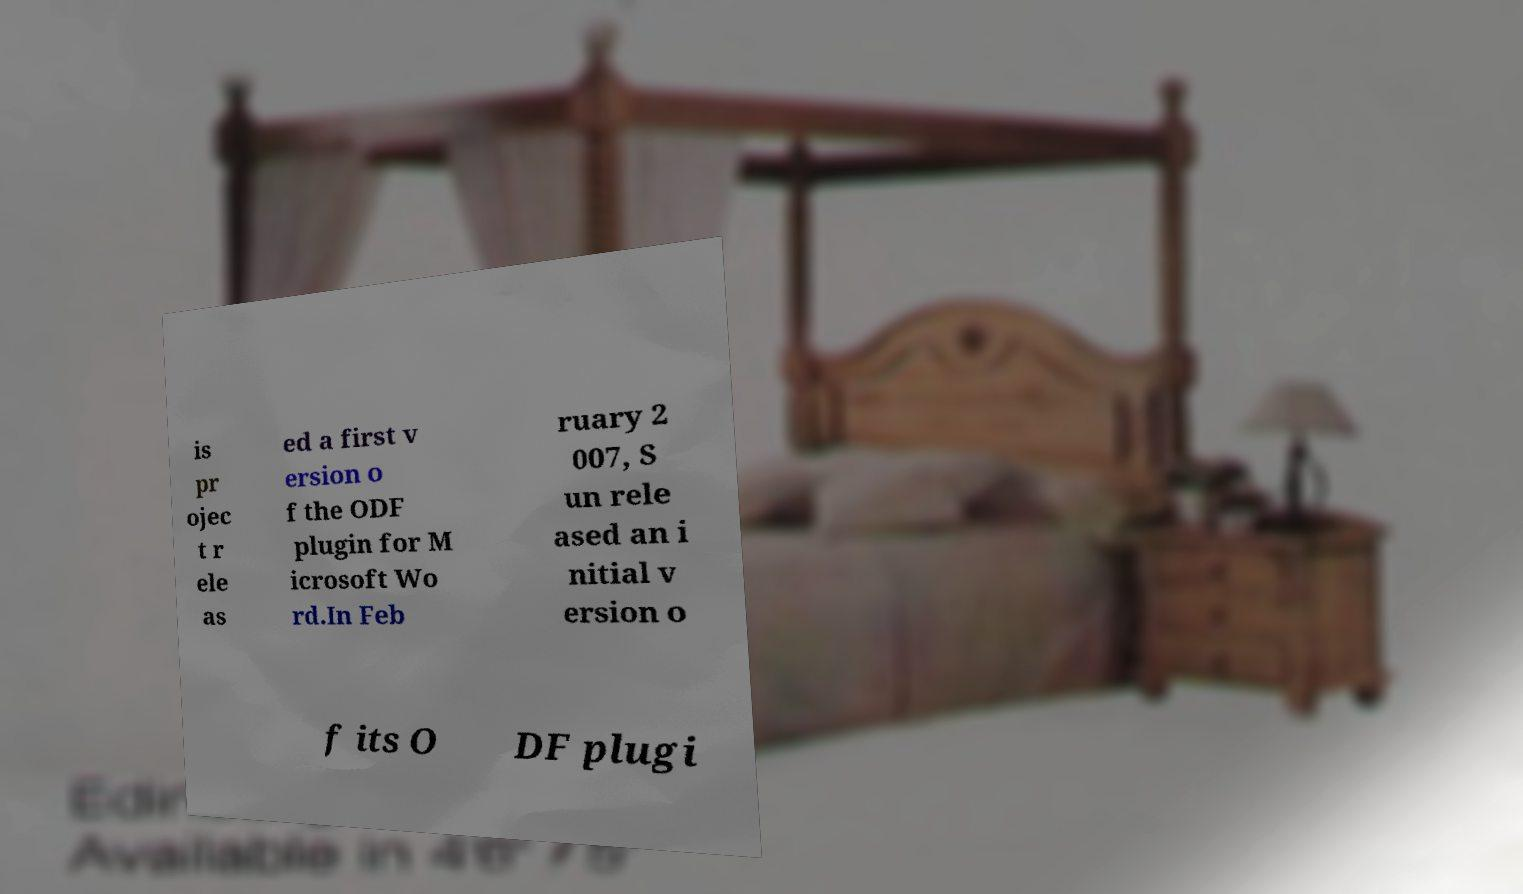Please read and relay the text visible in this image. What does it say? is pr ojec t r ele as ed a first v ersion o f the ODF plugin for M icrosoft Wo rd.In Feb ruary 2 007, S un rele ased an i nitial v ersion o f its O DF plugi 